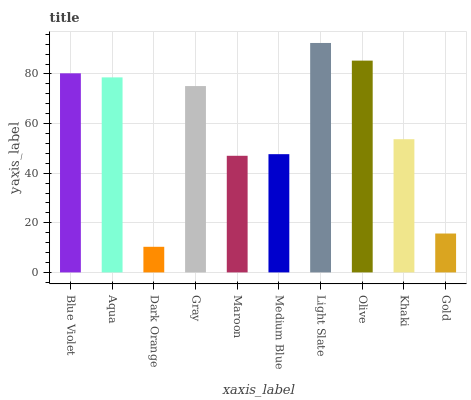Is Aqua the minimum?
Answer yes or no. No. Is Aqua the maximum?
Answer yes or no. No. Is Blue Violet greater than Aqua?
Answer yes or no. Yes. Is Aqua less than Blue Violet?
Answer yes or no. Yes. Is Aqua greater than Blue Violet?
Answer yes or no. No. Is Blue Violet less than Aqua?
Answer yes or no. No. Is Gray the high median?
Answer yes or no. Yes. Is Khaki the low median?
Answer yes or no. Yes. Is Olive the high median?
Answer yes or no. No. Is Light Slate the low median?
Answer yes or no. No. 